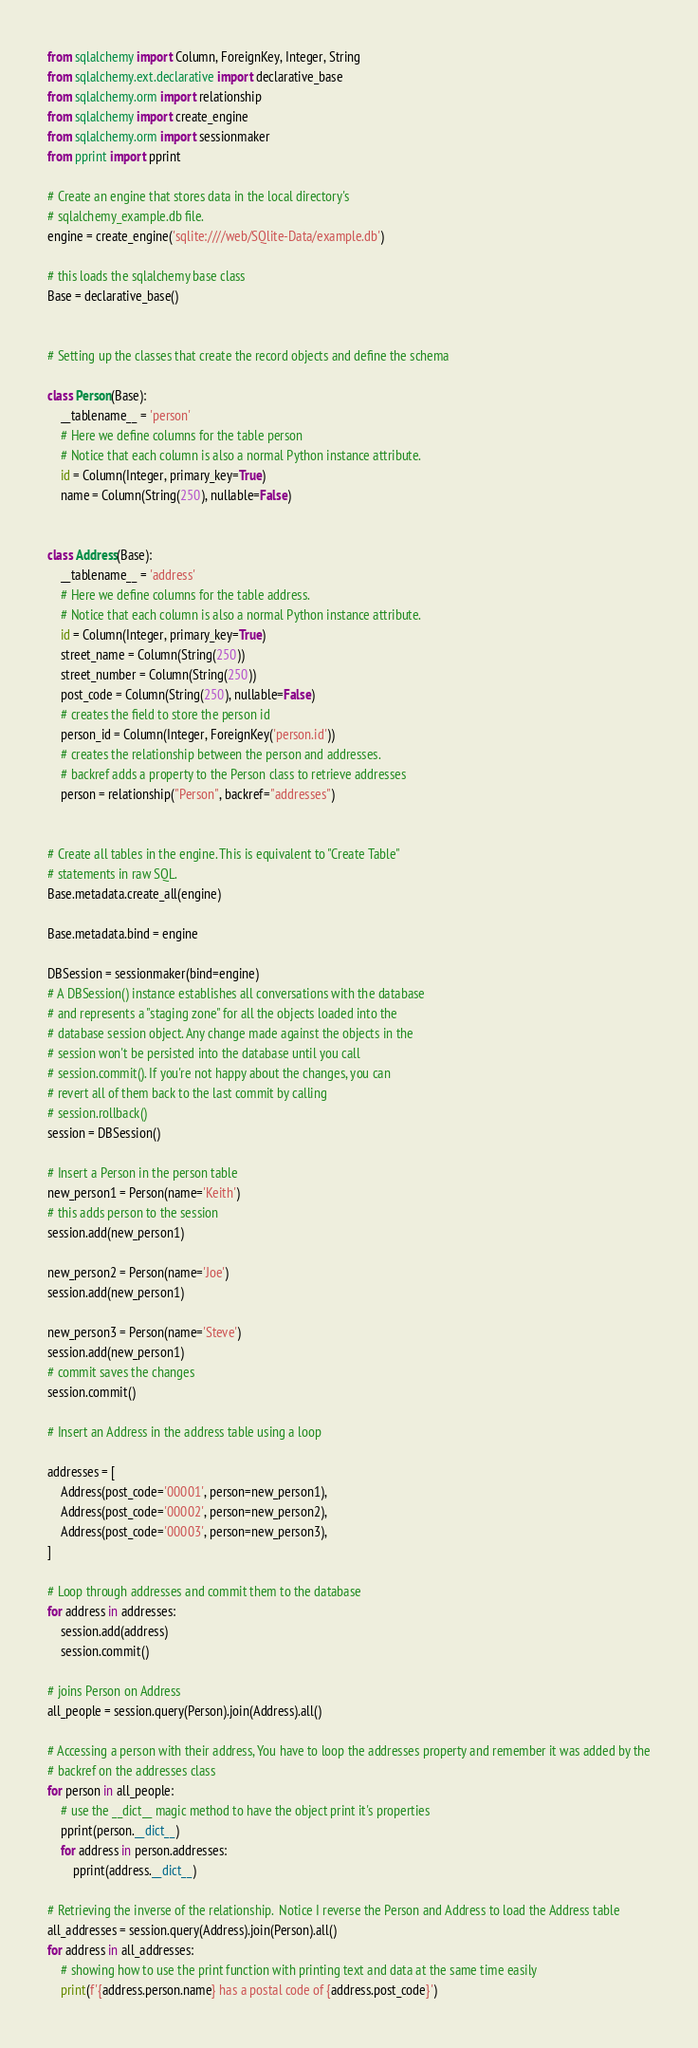<code> <loc_0><loc_0><loc_500><loc_500><_Python_>from sqlalchemy import Column, ForeignKey, Integer, String
from sqlalchemy.ext.declarative import declarative_base
from sqlalchemy.orm import relationship
from sqlalchemy import create_engine
from sqlalchemy.orm import sessionmaker
from pprint import pprint

# Create an engine that stores data in the local directory's
# sqlalchemy_example.db file.
engine = create_engine('sqlite:////web/SQlite-Data/example.db')

# this loads the sqlalchemy base class
Base = declarative_base()


# Setting up the classes that create the record objects and define the schema

class Person(Base):
    __tablename__ = 'person'
    # Here we define columns for the table person
    # Notice that each column is also a normal Python instance attribute.
    id = Column(Integer, primary_key=True)
    name = Column(String(250), nullable=False)


class Address(Base):
    __tablename__ = 'address'
    # Here we define columns for the table address.
    # Notice that each column is also a normal Python instance attribute.
    id = Column(Integer, primary_key=True)
    street_name = Column(String(250))
    street_number = Column(String(250))
    post_code = Column(String(250), nullable=False)
    # creates the field to store the person id
    person_id = Column(Integer, ForeignKey('person.id'))
    # creates the relationship between the person and addresses.
    # backref adds a property to the Person class to retrieve addresses
    person = relationship("Person", backref="addresses")


# Create all tables in the engine. This is equivalent to "Create Table"
# statements in raw SQL.
Base.metadata.create_all(engine)

Base.metadata.bind = engine

DBSession = sessionmaker(bind=engine)
# A DBSession() instance establishes all conversations with the database
# and represents a "staging zone" for all the objects loaded into the
# database session object. Any change made against the objects in the
# session won't be persisted into the database until you call
# session.commit(). If you're not happy about the changes, you can
# revert all of them back to the last commit by calling
# session.rollback()
session = DBSession()

# Insert a Person in the person table
new_person1 = Person(name='Keith')
# this adds person to the session
session.add(new_person1)

new_person2 = Person(name='Joe')
session.add(new_person1)

new_person3 = Person(name='Steve')
session.add(new_person1)
# commit saves the changes
session.commit()

# Insert an Address in the address table using a loop

addresses = [
    Address(post_code='00001', person=new_person1),
    Address(post_code='00002', person=new_person2),
    Address(post_code='00003', person=new_person3),
]

# Loop through addresses and commit them to the database
for address in addresses:
    session.add(address)
    session.commit()

# joins Person on Address
all_people = session.query(Person).join(Address).all()

# Accessing a person with their address, You have to loop the addresses property and remember it was added by the
# backref on the addresses class
for person in all_people:
    # use the __dict__ magic method to have the object print it's properties
    pprint(person.__dict__)
    for address in person.addresses:
        pprint(address.__dict__)

# Retrieving the inverse of the relationship.  Notice I reverse the Person and Address to load the Address table
all_addresses = session.query(Address).join(Person).all()
for address in all_addresses:
    # showing how to use the print function with printing text and data at the same time easily
    print(f'{address.person.name} has a postal code of {address.post_code}')</code> 